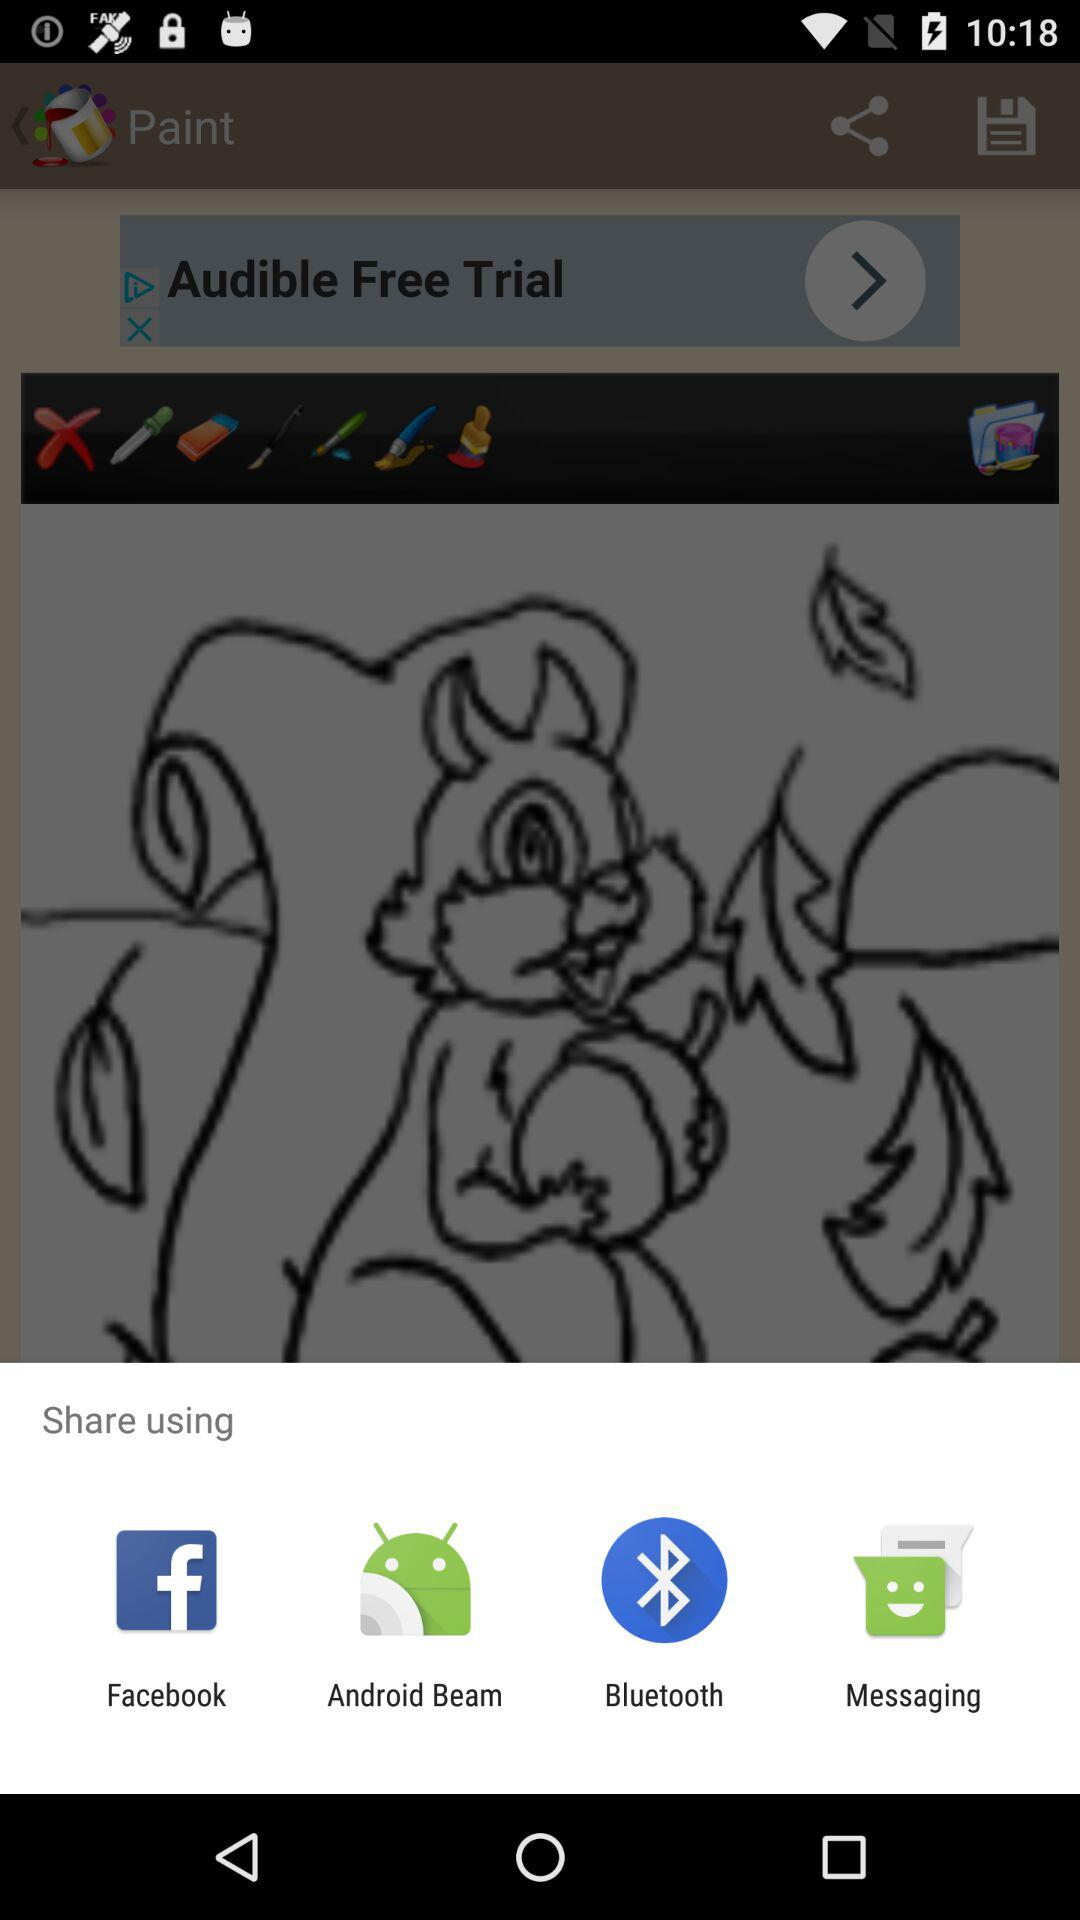What applications can we use to share? The applications are "Facebook", "Android Beam", "Bluetooth", and "Messaging". 